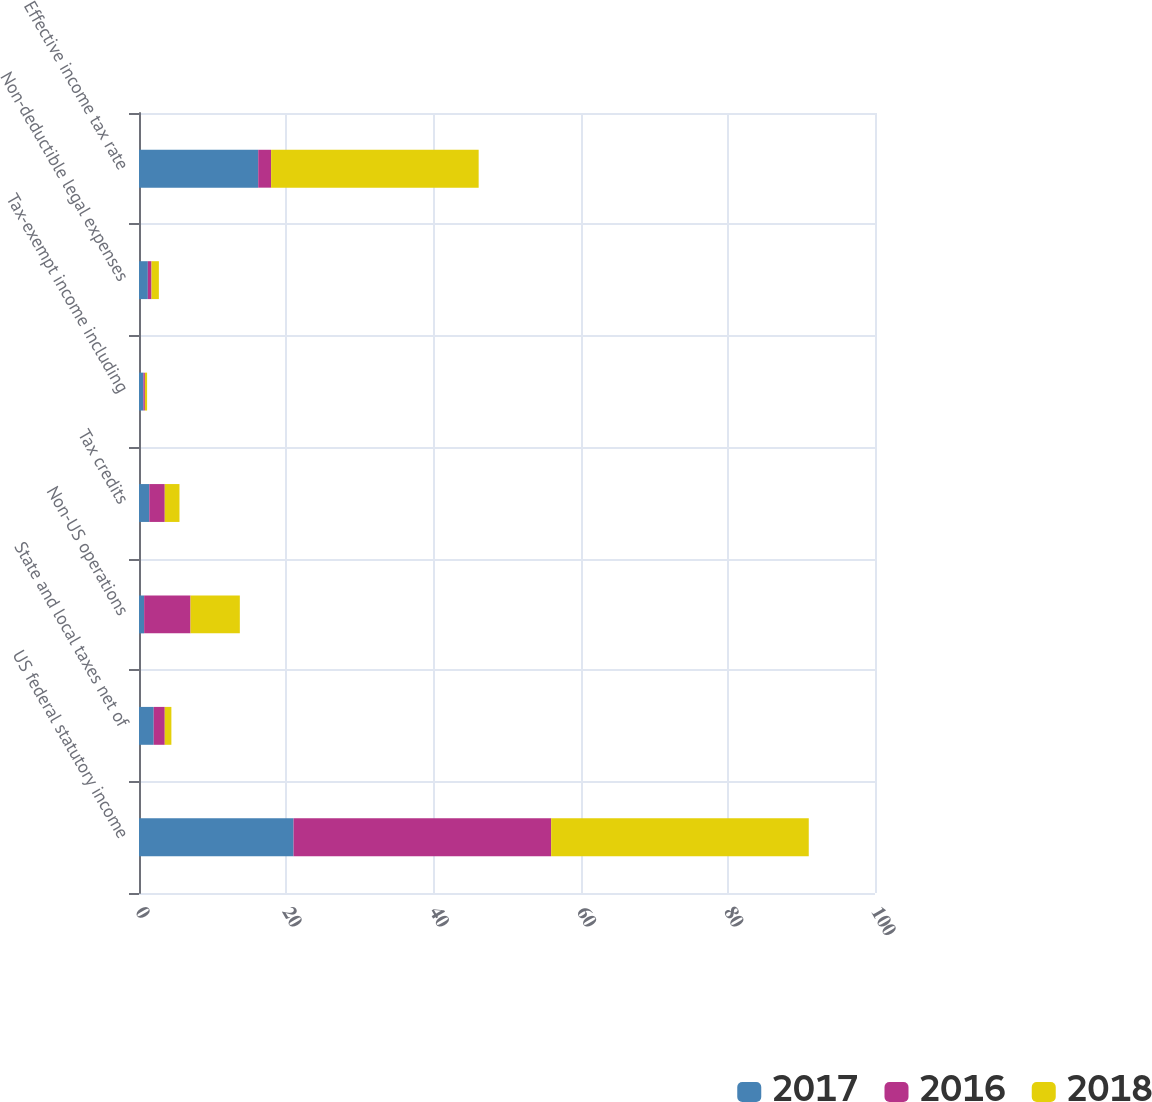Convert chart. <chart><loc_0><loc_0><loc_500><loc_500><stacked_bar_chart><ecel><fcel>US federal statutory income<fcel>State and local taxes net of<fcel>Non-US operations<fcel>Tax credits<fcel>Tax-exempt income including<fcel>Non-deductible legal expenses<fcel>Effective income tax rate<nl><fcel>2017<fcel>21<fcel>2<fcel>0.7<fcel>1.4<fcel>0.6<fcel>1.2<fcel>16.2<nl><fcel>2016<fcel>35<fcel>1.5<fcel>6.3<fcel>2.1<fcel>0.2<fcel>0.5<fcel>1.75<nl><fcel>2018<fcel>35<fcel>0.9<fcel>6.7<fcel>2<fcel>0.3<fcel>1<fcel>28.2<nl></chart> 